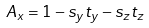<formula> <loc_0><loc_0><loc_500><loc_500>A _ { x } = 1 - s _ { y } t _ { y } - s _ { z } t _ { z }</formula> 